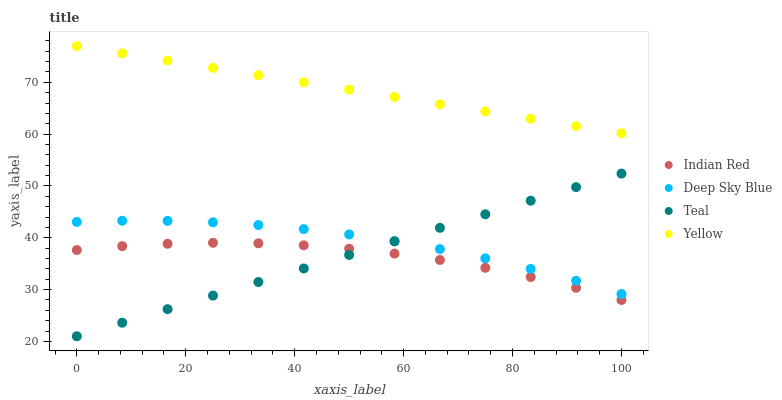Does Indian Red have the minimum area under the curve?
Answer yes or no. Yes. Does Yellow have the maximum area under the curve?
Answer yes or no. Yes. Does Deep Sky Blue have the minimum area under the curve?
Answer yes or no. No. Does Deep Sky Blue have the maximum area under the curve?
Answer yes or no. No. Is Yellow the smoothest?
Answer yes or no. Yes. Is Indian Red the roughest?
Answer yes or no. Yes. Is Deep Sky Blue the smoothest?
Answer yes or no. No. Is Deep Sky Blue the roughest?
Answer yes or no. No. Does Teal have the lowest value?
Answer yes or no. Yes. Does Deep Sky Blue have the lowest value?
Answer yes or no. No. Does Yellow have the highest value?
Answer yes or no. Yes. Does Deep Sky Blue have the highest value?
Answer yes or no. No. Is Indian Red less than Deep Sky Blue?
Answer yes or no. Yes. Is Yellow greater than Indian Red?
Answer yes or no. Yes. Does Teal intersect Deep Sky Blue?
Answer yes or no. Yes. Is Teal less than Deep Sky Blue?
Answer yes or no. No. Is Teal greater than Deep Sky Blue?
Answer yes or no. No. Does Indian Red intersect Deep Sky Blue?
Answer yes or no. No. 